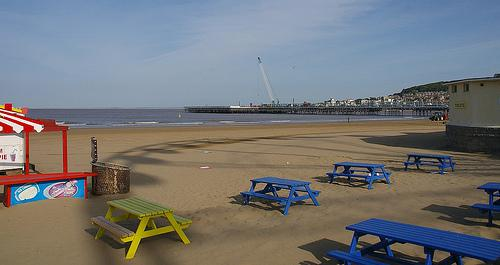Question: why is there sand?
Choices:
A. It's a sandbox.
B. For kids to play.
C. For the animals.
D. Beach.
Answer with the letter. Answer: D Question: who is in the picture?
Choices:
A. No one.
B. A man.
C. A couple.
D. A family.
Answer with the letter. Answer: A Question: what makes the shadow?
Choices:
A. Carousel.
B. Rollercoaster.
C. Tent.
D. Ferris wheel.
Answer with the letter. Answer: D Question: when is the picture taken?
Choices:
A. Afternoon.
B. In the evening.
C. Day time.
D. In the morning.
Answer with the letter. Answer: C Question: how many yellow picnic tables are there?
Choices:
A. Two.
B. Three.
C. Four.
D. One.
Answer with the letter. Answer: D Question: what comes up to the sand?
Choices:
A. Water.
B. Waves.
C. Seaweed.
D. Crab.
Answer with the letter. Answer: A 